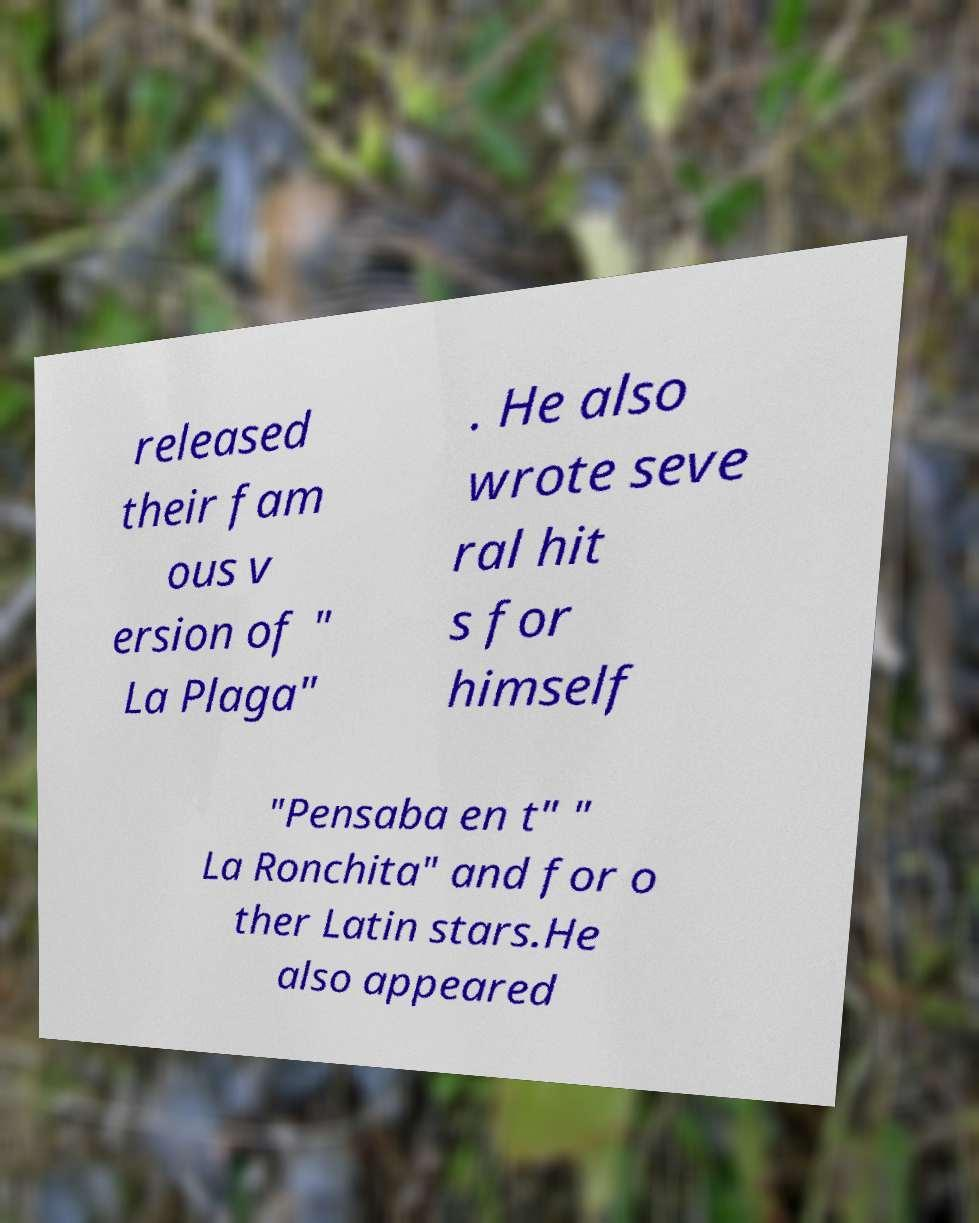For documentation purposes, I need the text within this image transcribed. Could you provide that? released their fam ous v ersion of " La Plaga" . He also wrote seve ral hit s for himself "Pensaba en t" " La Ronchita" and for o ther Latin stars.He also appeared 